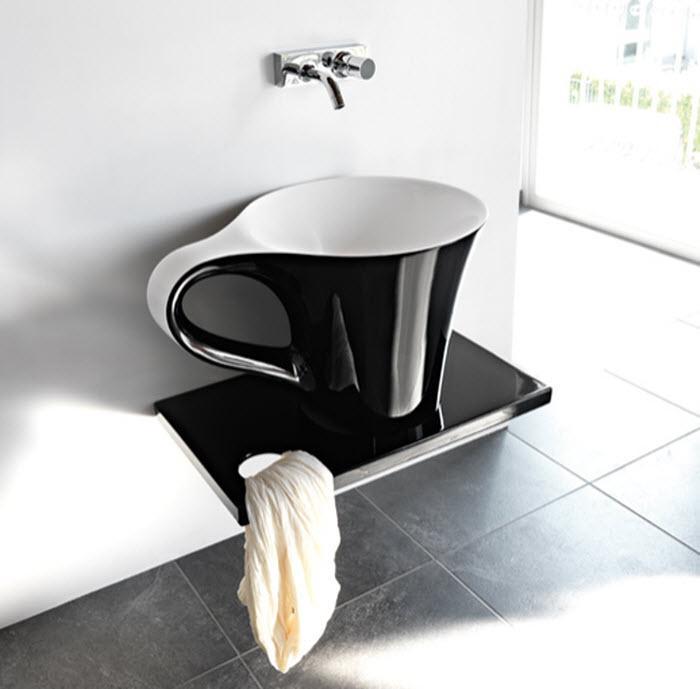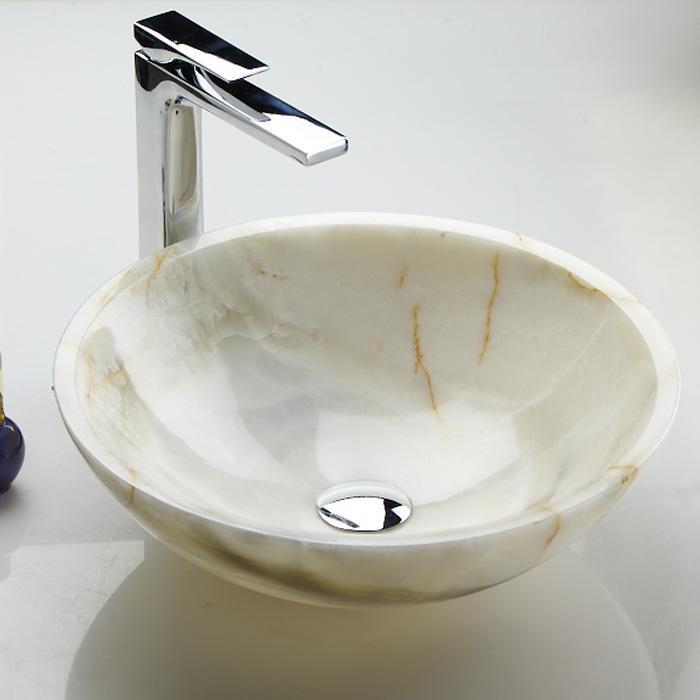The first image is the image on the left, the second image is the image on the right. Analyze the images presented: Is the assertion "The sink in the image on the right is shaped like a bowl." valid? Answer yes or no. Yes. 